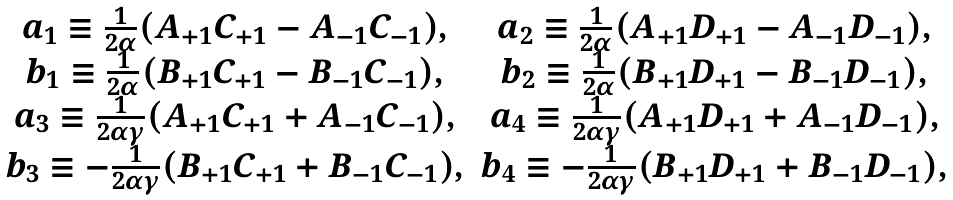Convert formula to latex. <formula><loc_0><loc_0><loc_500><loc_500>\begin{array} { c c } a _ { 1 } \equiv \frac { 1 } { 2 \alpha } ( A _ { + 1 } C _ { + 1 } - A _ { - 1 } C _ { - 1 } ) , & a _ { 2 } \equiv \frac { 1 } { 2 \alpha } ( A _ { + 1 } D _ { + 1 } - A _ { - 1 } D _ { - 1 } ) , \\ b _ { 1 } \equiv \frac { 1 } { 2 \alpha } ( B _ { + 1 } C _ { + 1 } - B _ { - 1 } C _ { - 1 } ) , & b _ { 2 } \equiv \frac { 1 } { 2 \alpha } ( B _ { + 1 } D _ { + 1 } - B _ { - 1 } D _ { - 1 } ) , \\ a _ { 3 } \equiv \frac { 1 } { 2 \alpha \gamma } ( A _ { + 1 } C _ { + 1 } + A _ { - 1 } C _ { - 1 } ) , & a _ { 4 } \equiv \frac { 1 } { 2 \alpha \gamma } ( A _ { + 1 } D _ { + 1 } + A _ { - 1 } D _ { - 1 } ) , \\ b _ { 3 } \equiv - \frac { 1 } { 2 \alpha \gamma } ( B _ { + 1 } C _ { + 1 } + B _ { - 1 } C _ { - 1 } ) , & b _ { 4 } \equiv - \frac { 1 } { 2 \alpha \gamma } ( B _ { + 1 } D _ { + 1 } + B _ { - 1 } D _ { - 1 } ) , \end{array}</formula> 